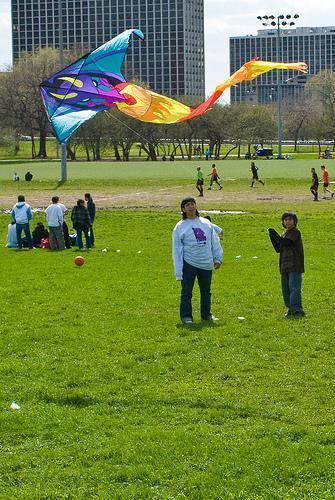How many people are running?
Give a very brief answer. 1. 